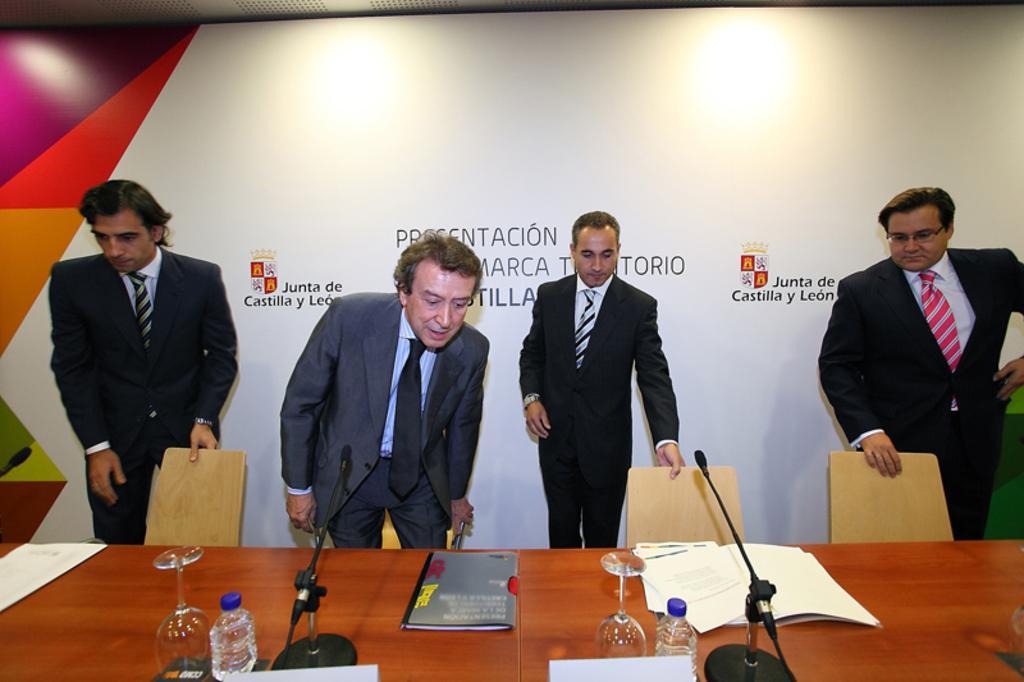In one or two sentences, can you explain what this image depicts? Here in this picture we can see four men standing over the place and we can see chairs in front of them and we can also see table in front of them and on that table we can see glasses, bottles of water, files, papers and microphones present all over there and behind them we can see banner present over there. 